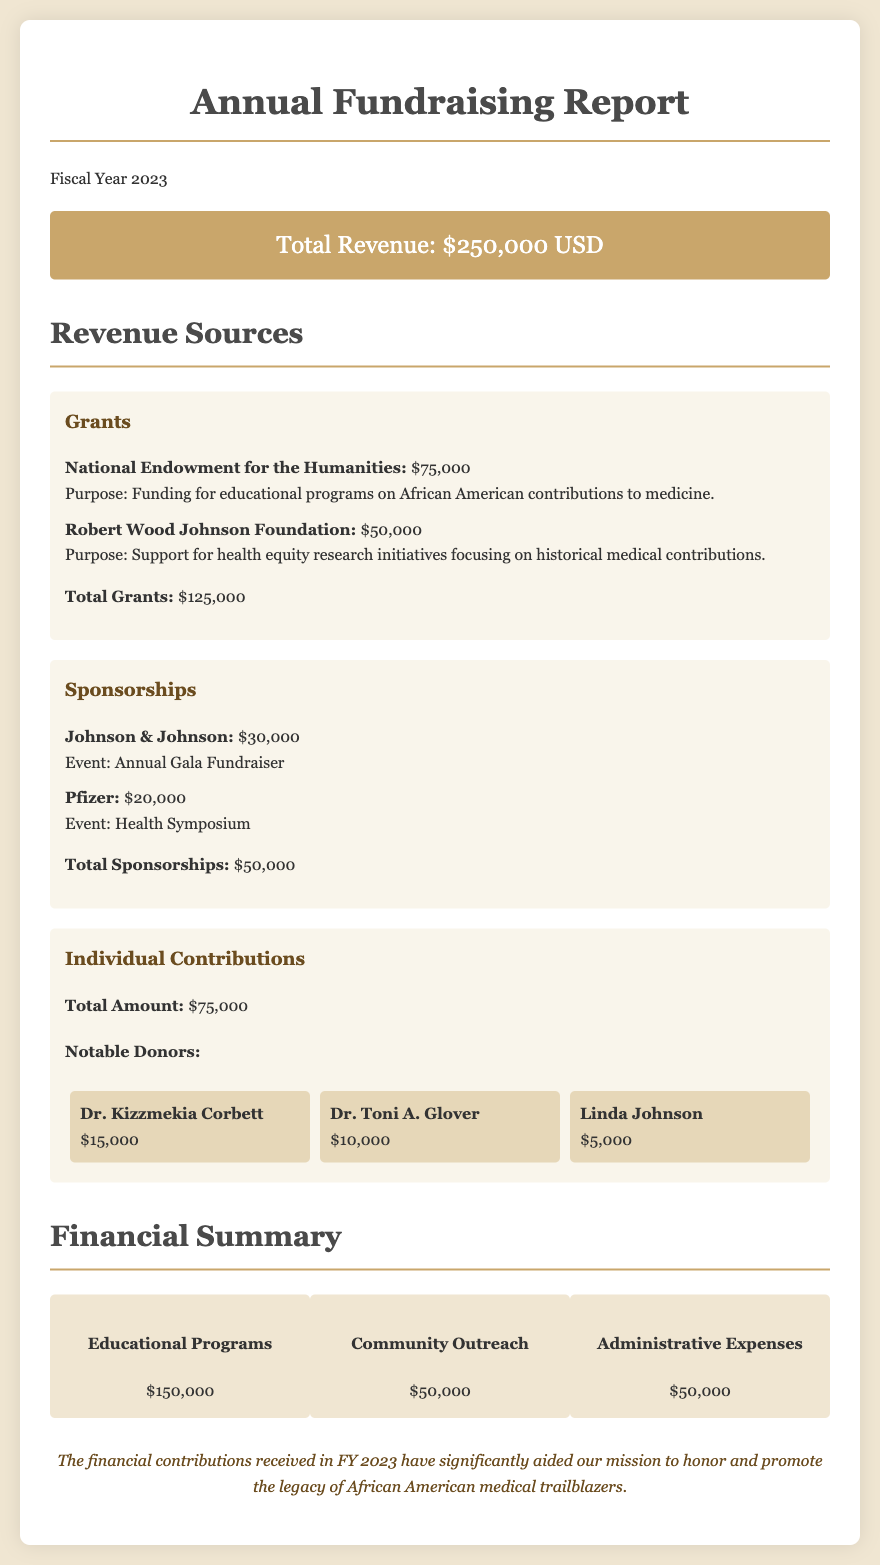what is the total revenue? The total revenue is displayed in the document and sums all revenue sources, which amounts to $250,000.
Answer: $250,000 how much did the National Endowment for the Humanities contribute? The contribution from the National Endowment for the Humanities is specifically listed in the grants section of the document, which is $75,000.
Answer: $75,000 who is one of the notable individual donors? The document highlights several notable individual donors, such as Dr. Kizzmekia Corbett, who is mentioned in the section for individual contributions.
Answer: Dr. Kizzmekia Corbett what is the total amount received from sponsorships? The total amount received from sponsorships is stated in the sponsorship section of the document, which adds up to $50,000.
Answer: $50,000 what was the purpose of the Robert Wood Johnson Foundation grant? The document specifies that the purpose of the Robert Wood Johnson Foundation grant was to support health equity research initiatives focusing on historical medical contributions.
Answer: Support for health equity research initiatives how much was allocated for educational programs? The document outlines various financial summaries and indicates that $150,000 was allocated for educational programs.
Answer: $150,000 who sponsored the Annual Gala Fundraiser? The sponsor of the Annual Gala Fundraiser is mentioned in the sponsorship section of the document as Johnson & Johnson.
Answer: Johnson & Johnson how many notable individual donors are mentioned? The document lists three notable individual donors in the individual contributions section, indicating their contributions.
Answer: Three what percentage of the total revenue comes from grants? To find the percentage from grants, we calculate (Total Grants / Total Revenue) x 100, which is (125000 / 250000) x 100 = 50%.
Answer: 50% 